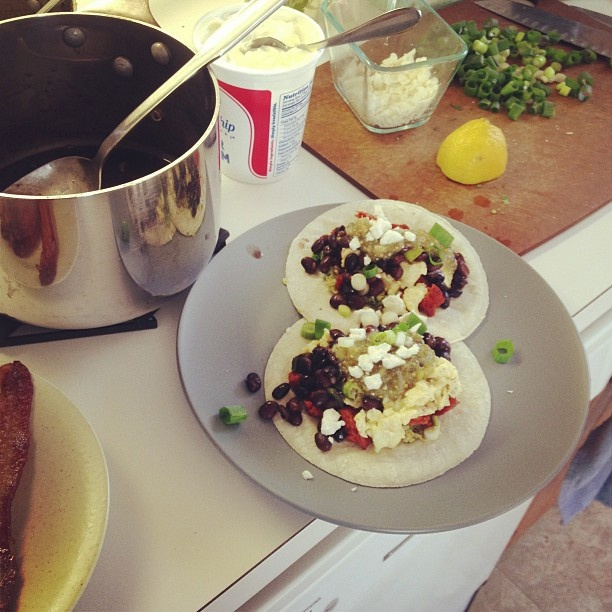Describe the objects in this image and their specific colors. I can see dining table in maroon, tan, beige, lightgray, and gray tones, bowl in maroon, tan, and gray tones, cup in maroon, beige, darkgray, and brown tones, bowl in maroon, khaki, tan, and gray tones, and spoon in maroon, lightyellow, gray, khaki, and brown tones in this image. 